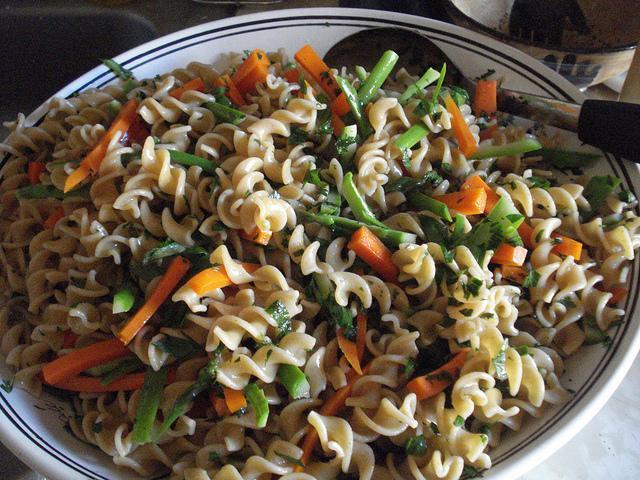How many carrots are there?
Give a very brief answer. 3. How many broccolis can you see?
Give a very brief answer. 1. How many people are wearing sunglasses?
Give a very brief answer. 0. 